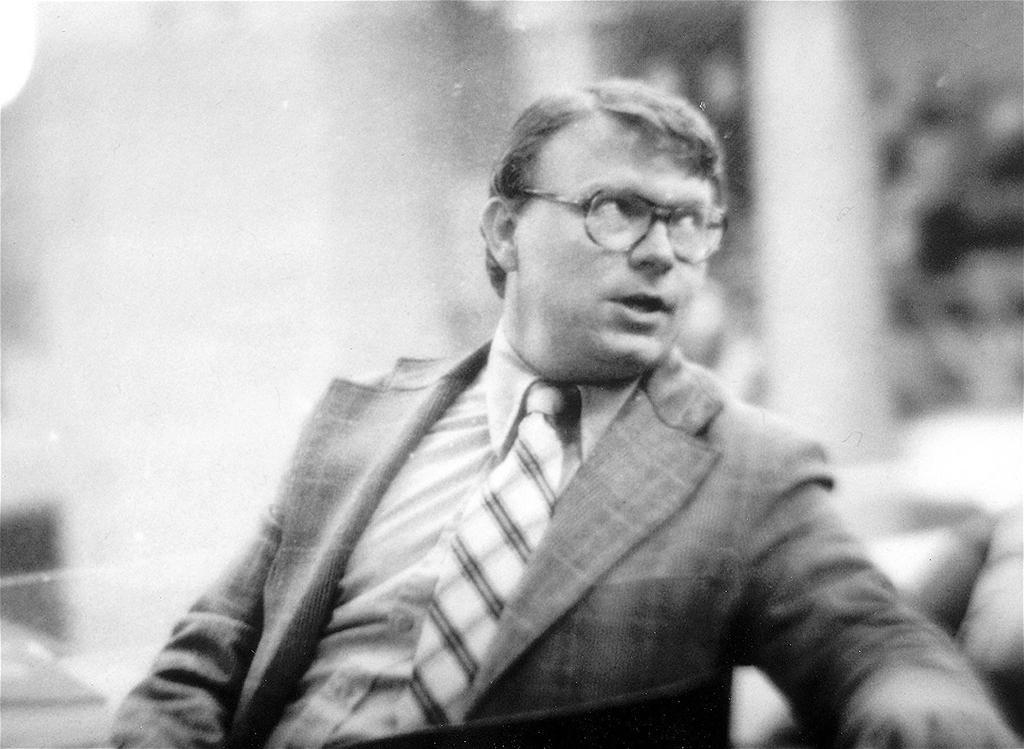Could you give a brief overview of what you see in this image? In this picture we can see a man sitting here, there is a blurry background, we can see this image is in black and white color. 